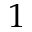<formula> <loc_0><loc_0><loc_500><loc_500>1</formula> 